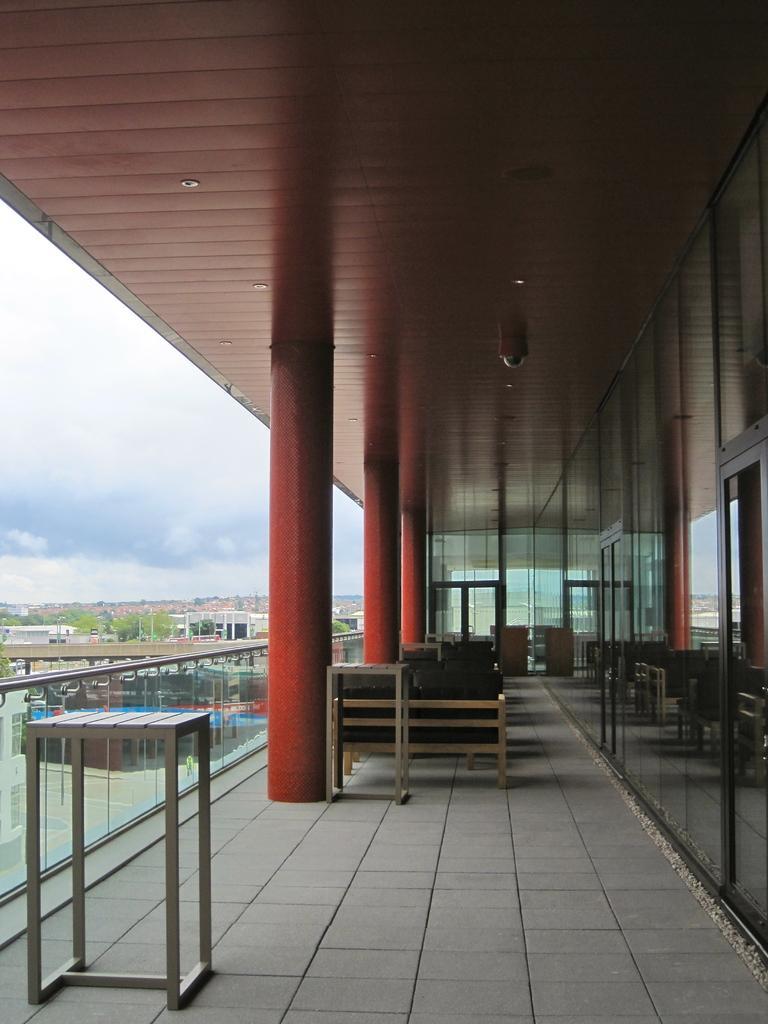Describe this image in one or two sentences. In this image there is a wall towards the right of the image, there is a floor towards the bottom of the image, there are objects on the floor, there are pillars, there are trees, there are buildings towards the left of the image, there is the sky towards the left of the image, there are clouds in the sky, there is a roof towards the top of the image. 